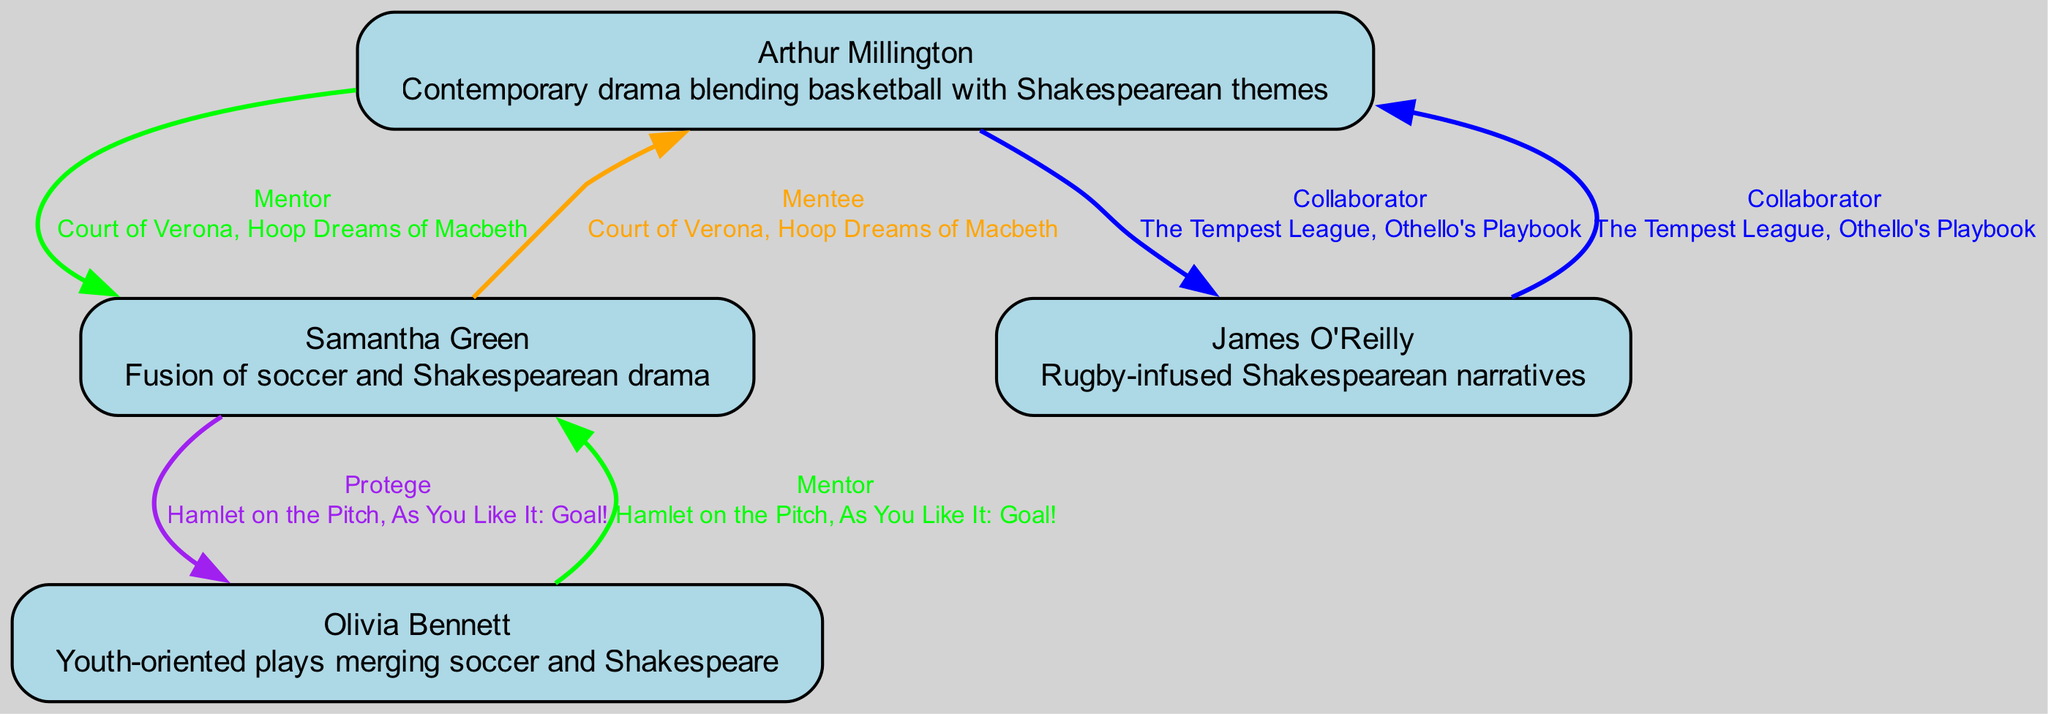What is the specialization of Arthur Millington? In the diagram, Arthur Millington is labeled with the specialization that describes his focus on contemporary drama blending basketball with Shakespearean themes. This information is directly presented in his node.
Answer: Contemporary drama blending basketball with Shakespearean themes Who is a mentee of Samantha Green? The diagram shows a relationship where Samantha Green has a collaboration with Arthur Millington labeled as "Mentee." This is specified in the collaboration details attached to Samantha's node.
Answer: Arthur Millington How many notable works are attributed to Olivia Bennett? By examining the collaborations listed under Olivia Bennett in the diagram, we see she has worked on two notable works: "Hamlet on the Pitch" and "As You Like It: Goal!" So, we count these to arrive at the answer.
Answer: 2 What is the relationship between James O'Reilly and Arthur Millington? The diagram indicates a "Collaborator" relationship between James O'Reilly and Arthur Millington. This is clearly stated in the edge connecting their nodes with the relationship label shown.
Answer: Collaborator Which playwright specializes in rugby-infused narratives? By reviewing the specializations given in the nodes, we can find that James O'Reilly is the playwright specifically focused on rugby-infused Shakespearean narratives, as stated in his node.
Answer: James O'Reilly How many total collaborations does Samantha Green have? Looking at the collaborations under Samantha Green, there are two listed: with Arthur Millington (as Mentee) and with Olivia Bennett (as Protege). We count these relationships to answer the question.
Answer: 2 Which color represents a "Protege" relationship in the diagram? The color coding used for different relationships is crucial in this diagram. The edge color for a "Protege" relationship is purple, as defined in the edge colors mapping section.
Answer: Purple What are the notable works of Arthur Millington and James O'Reilly? Analyzing the notable works listed for both playwrights, Arthur Millington's works are "Court of Verona" and "Hoop Dreams of Macbeth," while James O'Reilly's are "The Tempest League" and "Othello's Playbook." Therefore, we are consolidating and listing the works for both.
Answer: Court of Verona, Hoop Dreams of Macbeth; The Tempest League, Othello's Playbook 